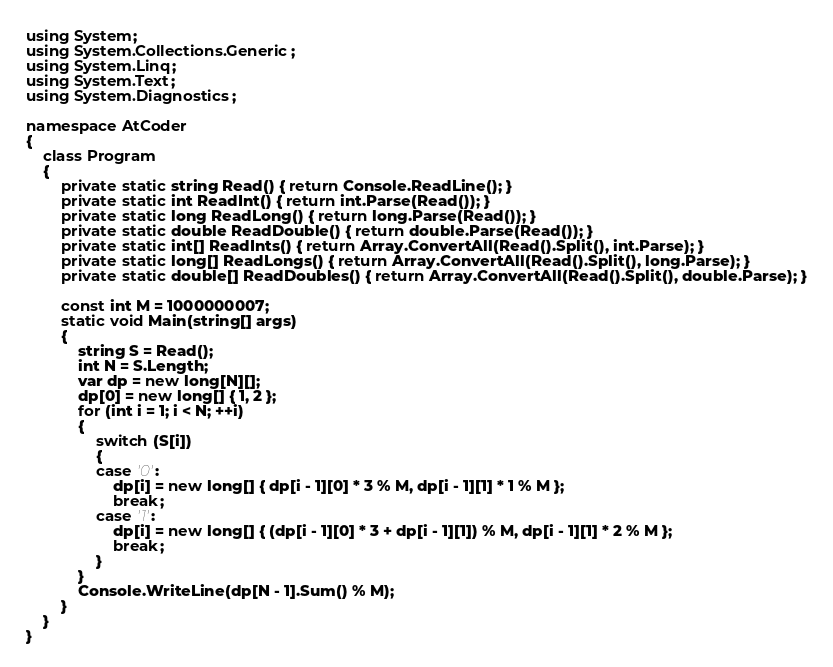<code> <loc_0><loc_0><loc_500><loc_500><_C#_>using System;
using System.Collections.Generic;
using System.Linq;
using System.Text;
using System.Diagnostics;

namespace AtCoder
{
    class Program
    {
        private static string Read() { return Console.ReadLine(); }
        private static int ReadInt() { return int.Parse(Read()); }
        private static long ReadLong() { return long.Parse(Read()); }
        private static double ReadDouble() { return double.Parse(Read()); }
        private static int[] ReadInts() { return Array.ConvertAll(Read().Split(), int.Parse); }
        private static long[] ReadLongs() { return Array.ConvertAll(Read().Split(), long.Parse); }
        private static double[] ReadDoubles() { return Array.ConvertAll(Read().Split(), double.Parse); }

        const int M = 1000000007;
        static void Main(string[] args)
        {
            string S = Read();
            int N = S.Length;
            var dp = new long[N][];
            dp[0] = new long[] { 1, 2 };
            for (int i = 1; i < N; ++i)
            {
                switch (S[i])
                {
                case '0':
                    dp[i] = new long[] { dp[i - 1][0] * 3 % M, dp[i - 1][1] * 1 % M };
                    break;
                case '1':
                    dp[i] = new long[] { (dp[i - 1][0] * 3 + dp[i - 1][1]) % M, dp[i - 1][1] * 2 % M };
                    break;
                }
            }
            Console.WriteLine(dp[N - 1].Sum() % M);
        }
    }
}
</code> 